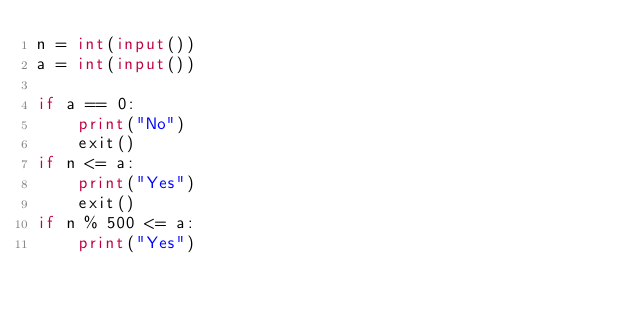<code> <loc_0><loc_0><loc_500><loc_500><_Python_>n = int(input())
a = int(input())

if a == 0:
    print("No")
    exit()
if n <= a:
    print("Yes")
    exit()
if n % 500 <= a:
    print("Yes")
</code> 